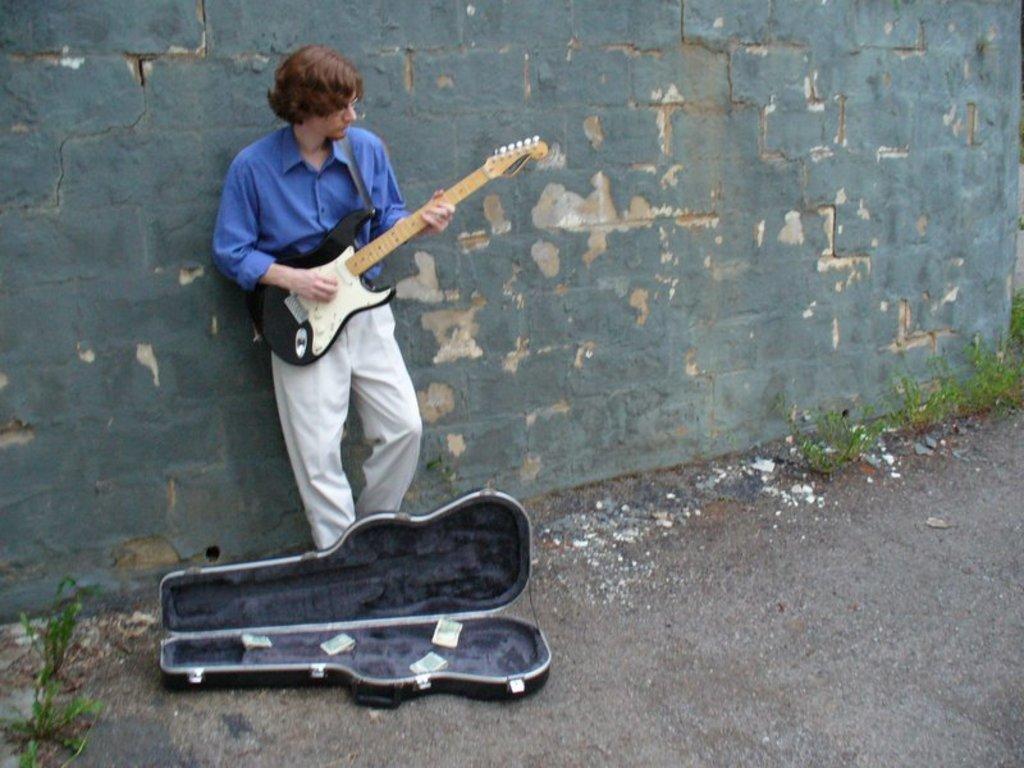How would you summarize this image in a sentence or two? In this image I see a man who is standing and holding a guitar in his hands, I can also see a box over here on the ground and there are few plants. In the background I see the wall. 